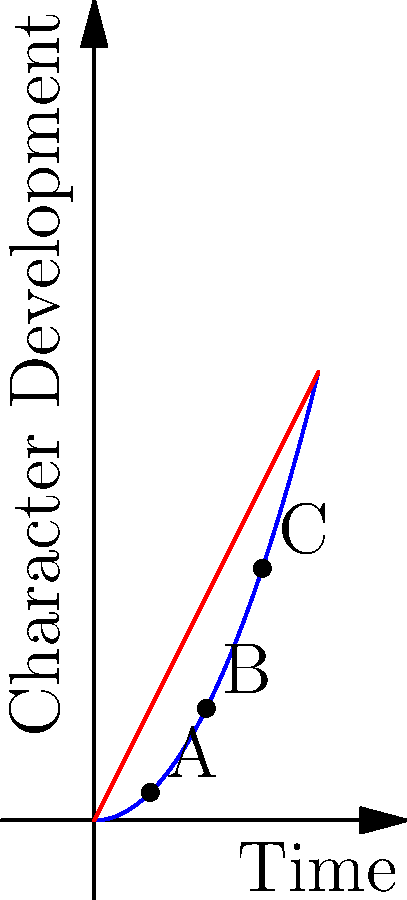In the graph above, which point represents the most significant moment of character growth in relation to the linear timeline? To determine the point of most significant character growth, we need to analyze the relationship between the character arc (blue curve) and the linear timeline (red line):

1. The blue curve represents the character's development over time.
2. The red line represents a linear progression of time.
3. The steepness of the blue curve indicates the rate of character growth.

Step-by-step analysis:
1. Point A (1, f(1)): The curve is relatively flat, indicating slow initial growth.
2. Point B (2, f(2)): The curve becomes steeper, showing accelerated growth.
3. Point C (3, f(3)): The curve is at its steepest, representing the most rapid growth.

The point where the blue curve is furthest from the red line and has the steepest slope represents the most significant moment of character growth relative to the linear timeline.

This occurs at point C, where the character's development is progressing much faster than the linear passage of time would suggest.
Answer: C 